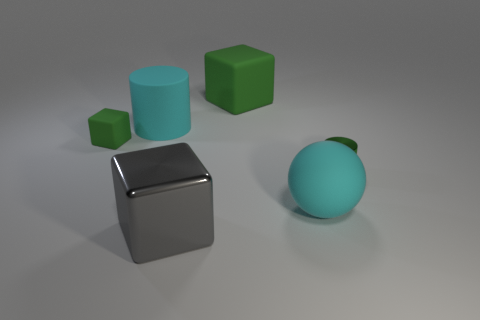Are the lighting conditions consistent across the objects in this image? Yes, the lighting conditions appear uniform across the scene. All objects display shadows extending to the right, which suggests a single light source coming from the left. The intensity and softness of the light create soft shadows, and the direction is consistent for all items, establishing a harmonious lighting environment. 